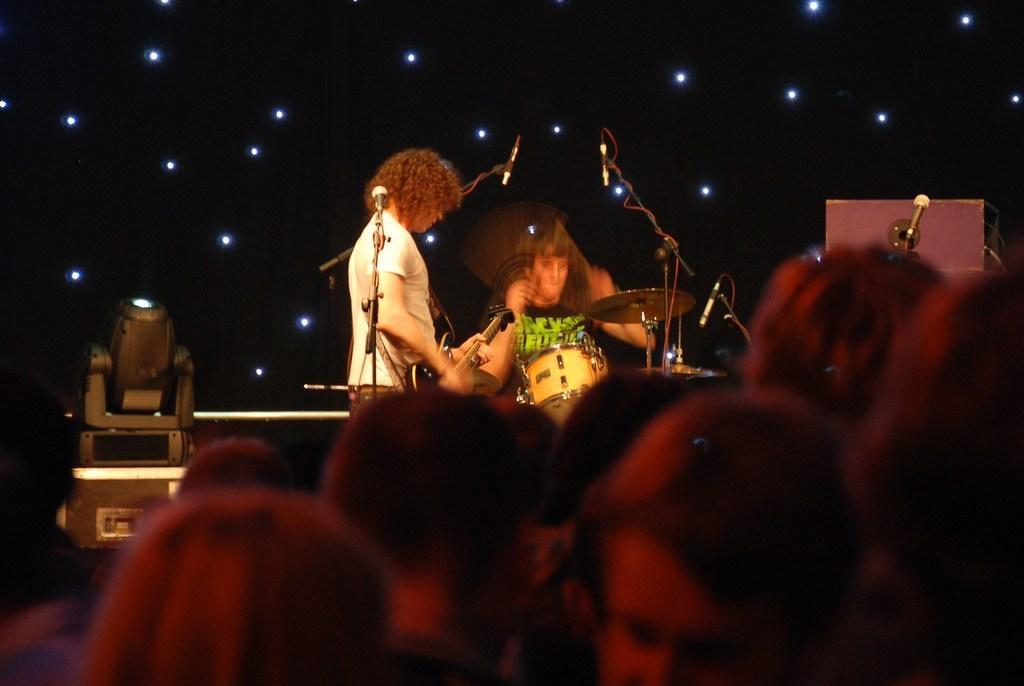In one or two sentences, can you explain what this image depicts? In this image we can see two persons are playing musical instruments. There are mikes and lights. At the bottom of the image we can see few people. 